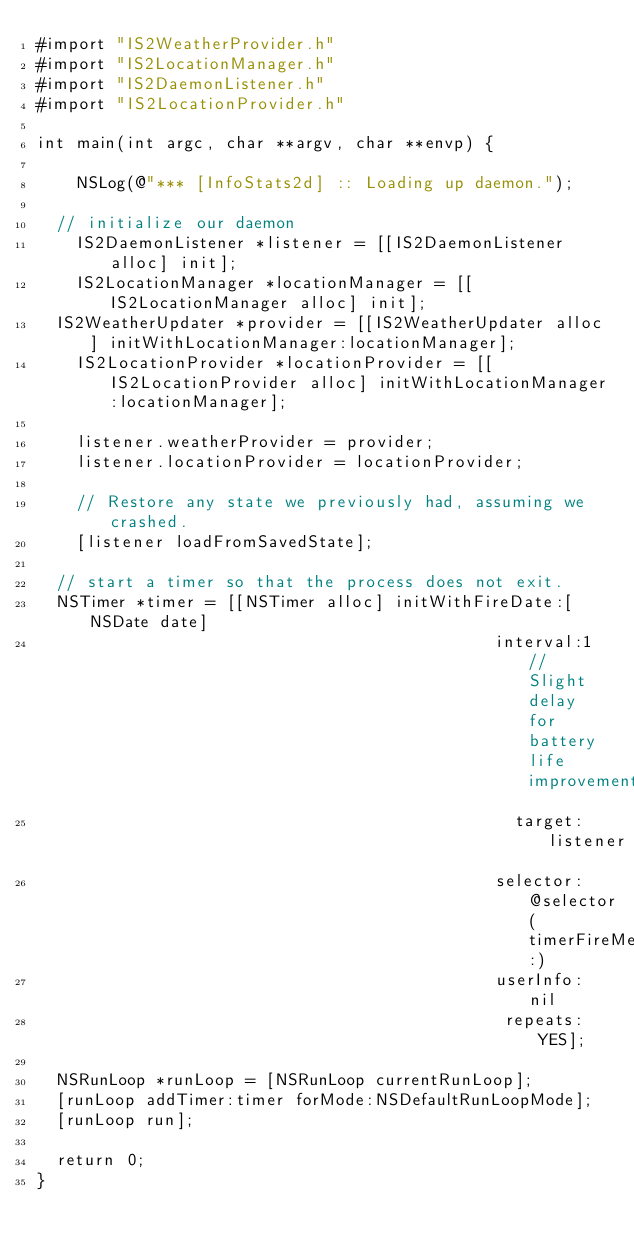Convert code to text. <code><loc_0><loc_0><loc_500><loc_500><_ObjectiveC_>#import "IS2WeatherProvider.h"
#import "IS2LocationManager.h"
#import "IS2DaemonListener.h"
#import "IS2LocationProvider.h"

int main(int argc, char **argv, char **envp) {
    
    NSLog(@"*** [InfoStats2d] :: Loading up daemon.");
    
	// initialize our daemon
    IS2DaemonListener *listener = [[IS2DaemonListener alloc] init];
    IS2LocationManager *locationManager = [[IS2LocationManager alloc] init];
	IS2WeatherUpdater *provider = [[IS2WeatherUpdater alloc] initWithLocationManager:locationManager];
    IS2LocationProvider *locationProvider = [[IS2LocationProvider alloc] initWithLocationManager:locationManager];
    
    listener.weatherProvider = provider;
    listener.locationProvider = locationProvider;
    
    // Restore any state we previously had, assuming we crashed.
    [listener loadFromSavedState];
    
	// start a timer so that the process does not exit.
	NSTimer *timer = [[NSTimer alloc] initWithFireDate:[NSDate date]
                                              interval:1 // Slight delay for battery life improvements
                                                target:listener
                                              selector:@selector(timerFireMethod:)
                                              userInfo:nil
                                               repeats:YES];
    
	NSRunLoop *runLoop = [NSRunLoop currentRunLoop];
	[runLoop addTimer:timer forMode:NSDefaultRunLoopMode];
	[runLoop run];
    
	return 0;
}</code> 